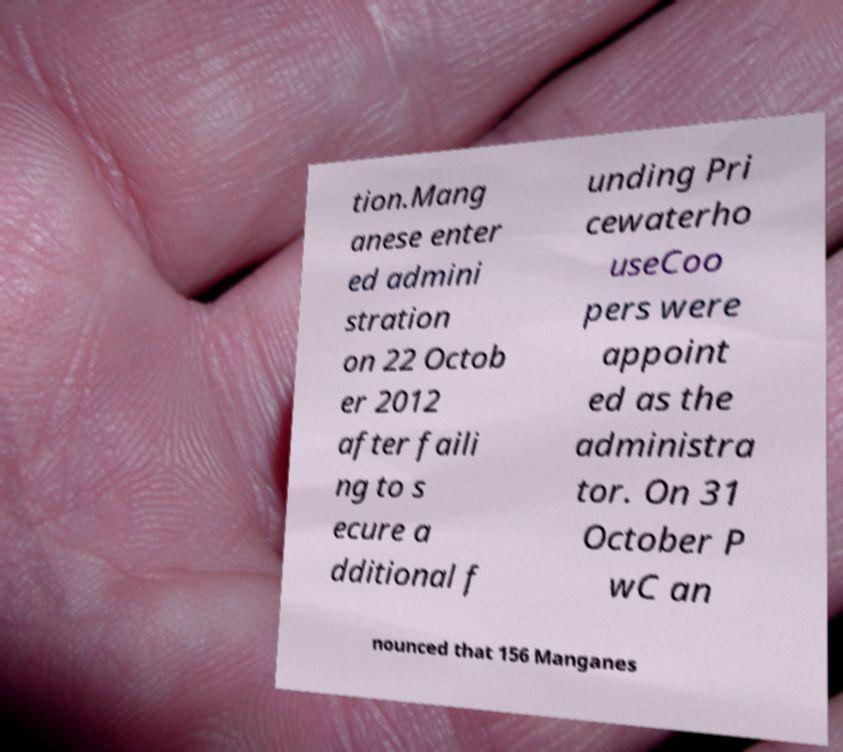I need the written content from this picture converted into text. Can you do that? tion.Mang anese enter ed admini stration on 22 Octob er 2012 after faili ng to s ecure a dditional f unding Pri cewaterho useCoo pers were appoint ed as the administra tor. On 31 October P wC an nounced that 156 Manganes 